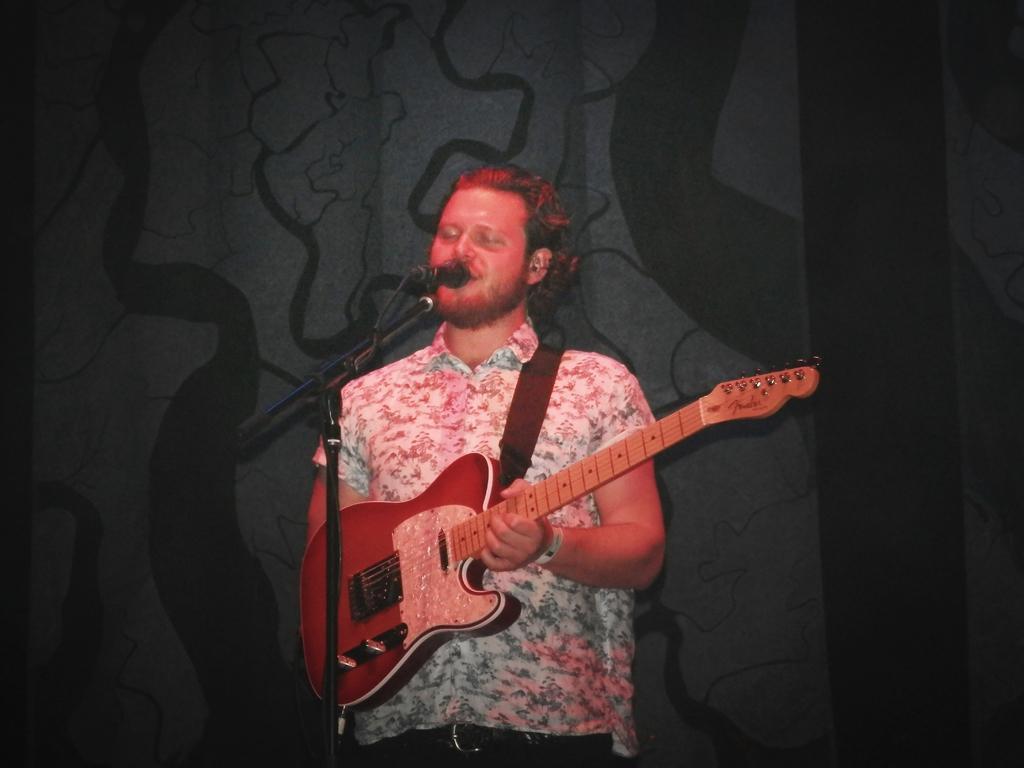In one or two sentences, can you explain what this image depicts? Here we can see that a man standing on the floor and singing, and he is holding a guitar in his hands, and in front here is the microphone and stand. 